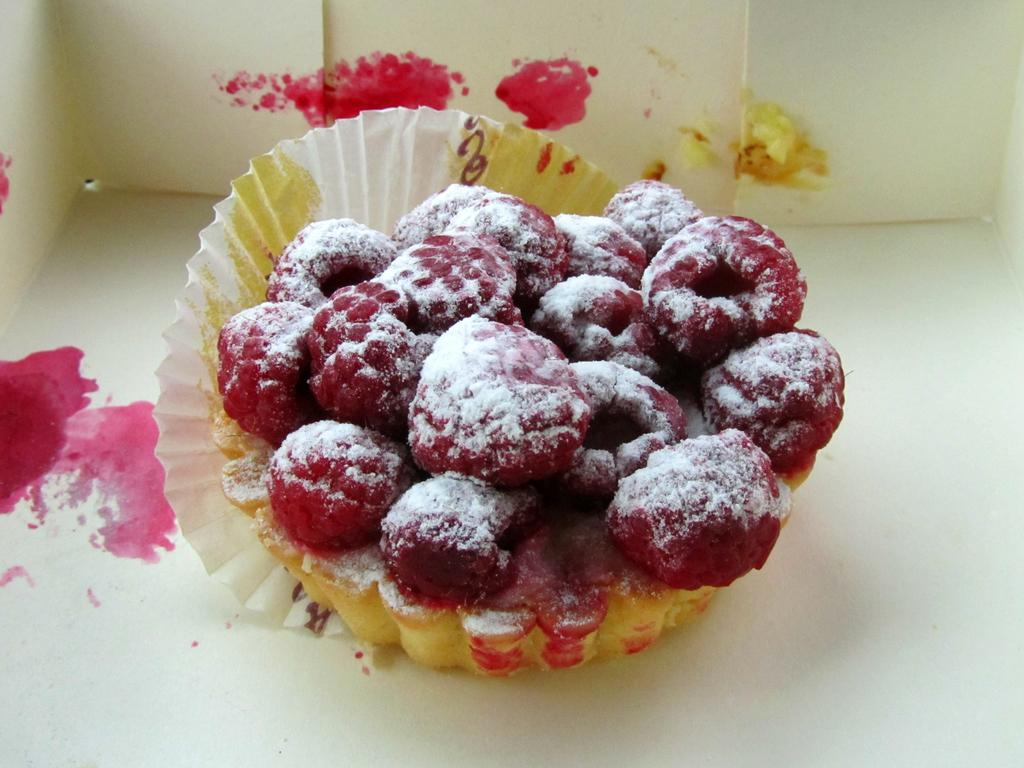What is the main subject of the image? The main subject of the image is a cake. How is the cake packaged or protected? The cake is in a wrapper. Where is the cake located in the image? The cake is placed on a surface. What decoration or topping is visible on the cake? There are strawberries on top of the cake. What type of verse can be read on the side of the cake in the image? There is no verse present on the side of the cake in the image. 